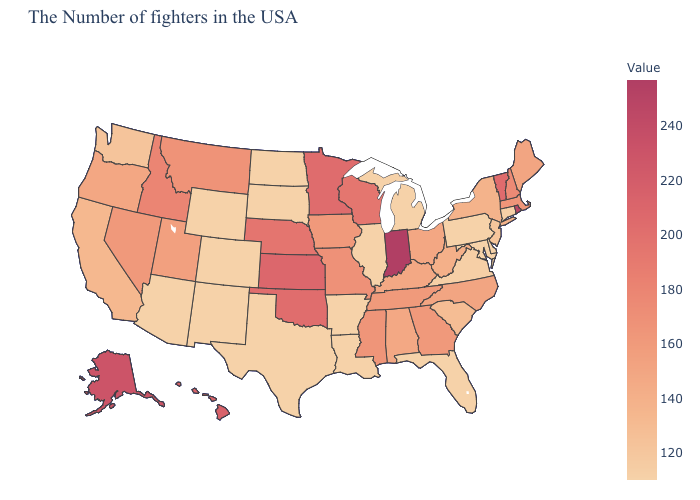Is the legend a continuous bar?
Quick response, please. Yes. Does the map have missing data?
Write a very short answer. No. Is the legend a continuous bar?
Be succinct. Yes. Does Vermont have the lowest value in the USA?
Be succinct. No. Which states have the highest value in the USA?
Quick response, please. Indiana. Is the legend a continuous bar?
Keep it brief. Yes. Does Montana have the highest value in the USA?
Write a very short answer. No. 